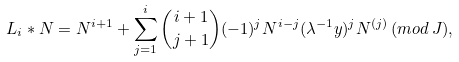<formula> <loc_0><loc_0><loc_500><loc_500>L _ { i } * N = N ^ { i + 1 } + \sum _ { j = 1 } ^ { i } \binom { i + 1 } { j + 1 } ( - 1 ) ^ { j } N ^ { i - j } ( \lambda ^ { - 1 } y ) ^ { j } N ^ { ( j ) } \, ( m o d \, J ) ,</formula> 